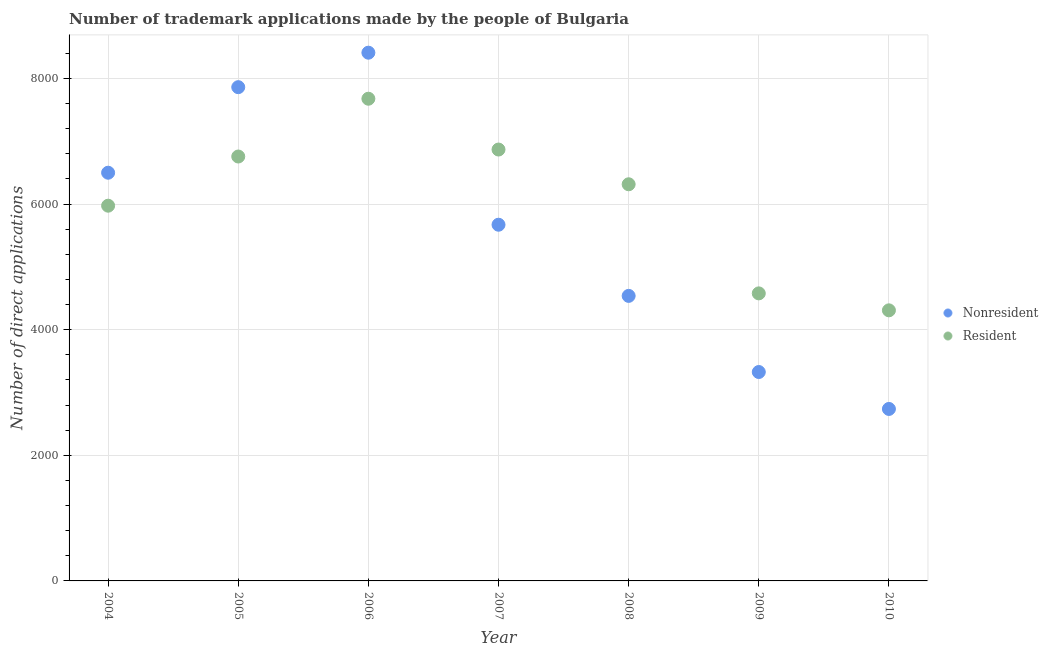What is the number of trademark applications made by non residents in 2004?
Offer a very short reply. 6499. Across all years, what is the maximum number of trademark applications made by non residents?
Provide a short and direct response. 8410. Across all years, what is the minimum number of trademark applications made by residents?
Give a very brief answer. 4308. In which year was the number of trademark applications made by residents maximum?
Your answer should be compact. 2006. In which year was the number of trademark applications made by residents minimum?
Provide a short and direct response. 2010. What is the total number of trademark applications made by non residents in the graph?
Your response must be concise. 3.90e+04. What is the difference between the number of trademark applications made by non residents in 2006 and that in 2009?
Your answer should be very brief. 5084. What is the difference between the number of trademark applications made by residents in 2008 and the number of trademark applications made by non residents in 2004?
Provide a short and direct response. -184. What is the average number of trademark applications made by residents per year?
Your response must be concise. 6068.14. In the year 2005, what is the difference between the number of trademark applications made by non residents and number of trademark applications made by residents?
Ensure brevity in your answer.  1104. In how many years, is the number of trademark applications made by residents greater than 5200?
Make the answer very short. 5. What is the ratio of the number of trademark applications made by residents in 2005 to that in 2010?
Your answer should be very brief. 1.57. Is the difference between the number of trademark applications made by residents in 2004 and 2010 greater than the difference between the number of trademark applications made by non residents in 2004 and 2010?
Offer a terse response. No. What is the difference between the highest and the second highest number of trademark applications made by residents?
Your answer should be very brief. 809. What is the difference between the highest and the lowest number of trademark applications made by residents?
Offer a terse response. 3369. In how many years, is the number of trademark applications made by non residents greater than the average number of trademark applications made by non residents taken over all years?
Provide a short and direct response. 4. Is the sum of the number of trademark applications made by non residents in 2004 and 2008 greater than the maximum number of trademark applications made by residents across all years?
Make the answer very short. Yes. Does the number of trademark applications made by non residents monotonically increase over the years?
Your answer should be compact. No. Is the number of trademark applications made by residents strictly less than the number of trademark applications made by non residents over the years?
Ensure brevity in your answer.  No. How many years are there in the graph?
Provide a short and direct response. 7. Does the graph contain any zero values?
Provide a succinct answer. No. Where does the legend appear in the graph?
Your answer should be very brief. Center right. How many legend labels are there?
Offer a terse response. 2. What is the title of the graph?
Ensure brevity in your answer.  Number of trademark applications made by the people of Bulgaria. What is the label or title of the Y-axis?
Make the answer very short. Number of direct applications. What is the Number of direct applications in Nonresident in 2004?
Your response must be concise. 6499. What is the Number of direct applications of Resident in 2004?
Your response must be concise. 5974. What is the Number of direct applications of Nonresident in 2005?
Provide a short and direct response. 7861. What is the Number of direct applications of Resident in 2005?
Offer a terse response. 6757. What is the Number of direct applications of Nonresident in 2006?
Your answer should be very brief. 8410. What is the Number of direct applications of Resident in 2006?
Ensure brevity in your answer.  7677. What is the Number of direct applications of Nonresident in 2007?
Provide a succinct answer. 5671. What is the Number of direct applications in Resident in 2007?
Provide a succinct answer. 6868. What is the Number of direct applications in Nonresident in 2008?
Keep it short and to the point. 4538. What is the Number of direct applications in Resident in 2008?
Your answer should be very brief. 6315. What is the Number of direct applications in Nonresident in 2009?
Your response must be concise. 3326. What is the Number of direct applications of Resident in 2009?
Your answer should be very brief. 4578. What is the Number of direct applications of Nonresident in 2010?
Make the answer very short. 2738. What is the Number of direct applications of Resident in 2010?
Your answer should be very brief. 4308. Across all years, what is the maximum Number of direct applications of Nonresident?
Offer a terse response. 8410. Across all years, what is the maximum Number of direct applications in Resident?
Make the answer very short. 7677. Across all years, what is the minimum Number of direct applications of Nonresident?
Your response must be concise. 2738. Across all years, what is the minimum Number of direct applications of Resident?
Offer a terse response. 4308. What is the total Number of direct applications of Nonresident in the graph?
Ensure brevity in your answer.  3.90e+04. What is the total Number of direct applications of Resident in the graph?
Give a very brief answer. 4.25e+04. What is the difference between the Number of direct applications in Nonresident in 2004 and that in 2005?
Your response must be concise. -1362. What is the difference between the Number of direct applications of Resident in 2004 and that in 2005?
Ensure brevity in your answer.  -783. What is the difference between the Number of direct applications in Nonresident in 2004 and that in 2006?
Offer a terse response. -1911. What is the difference between the Number of direct applications of Resident in 2004 and that in 2006?
Your answer should be compact. -1703. What is the difference between the Number of direct applications in Nonresident in 2004 and that in 2007?
Provide a succinct answer. 828. What is the difference between the Number of direct applications of Resident in 2004 and that in 2007?
Your answer should be very brief. -894. What is the difference between the Number of direct applications of Nonresident in 2004 and that in 2008?
Your response must be concise. 1961. What is the difference between the Number of direct applications in Resident in 2004 and that in 2008?
Give a very brief answer. -341. What is the difference between the Number of direct applications in Nonresident in 2004 and that in 2009?
Give a very brief answer. 3173. What is the difference between the Number of direct applications of Resident in 2004 and that in 2009?
Your answer should be compact. 1396. What is the difference between the Number of direct applications of Nonresident in 2004 and that in 2010?
Your answer should be compact. 3761. What is the difference between the Number of direct applications of Resident in 2004 and that in 2010?
Ensure brevity in your answer.  1666. What is the difference between the Number of direct applications in Nonresident in 2005 and that in 2006?
Give a very brief answer. -549. What is the difference between the Number of direct applications in Resident in 2005 and that in 2006?
Make the answer very short. -920. What is the difference between the Number of direct applications of Nonresident in 2005 and that in 2007?
Make the answer very short. 2190. What is the difference between the Number of direct applications of Resident in 2005 and that in 2007?
Provide a short and direct response. -111. What is the difference between the Number of direct applications of Nonresident in 2005 and that in 2008?
Your answer should be very brief. 3323. What is the difference between the Number of direct applications in Resident in 2005 and that in 2008?
Provide a succinct answer. 442. What is the difference between the Number of direct applications in Nonresident in 2005 and that in 2009?
Make the answer very short. 4535. What is the difference between the Number of direct applications of Resident in 2005 and that in 2009?
Give a very brief answer. 2179. What is the difference between the Number of direct applications of Nonresident in 2005 and that in 2010?
Ensure brevity in your answer.  5123. What is the difference between the Number of direct applications of Resident in 2005 and that in 2010?
Offer a terse response. 2449. What is the difference between the Number of direct applications of Nonresident in 2006 and that in 2007?
Your response must be concise. 2739. What is the difference between the Number of direct applications in Resident in 2006 and that in 2007?
Your answer should be compact. 809. What is the difference between the Number of direct applications in Nonresident in 2006 and that in 2008?
Your response must be concise. 3872. What is the difference between the Number of direct applications of Resident in 2006 and that in 2008?
Ensure brevity in your answer.  1362. What is the difference between the Number of direct applications of Nonresident in 2006 and that in 2009?
Your response must be concise. 5084. What is the difference between the Number of direct applications in Resident in 2006 and that in 2009?
Give a very brief answer. 3099. What is the difference between the Number of direct applications in Nonresident in 2006 and that in 2010?
Provide a short and direct response. 5672. What is the difference between the Number of direct applications in Resident in 2006 and that in 2010?
Ensure brevity in your answer.  3369. What is the difference between the Number of direct applications in Nonresident in 2007 and that in 2008?
Provide a succinct answer. 1133. What is the difference between the Number of direct applications of Resident in 2007 and that in 2008?
Your answer should be very brief. 553. What is the difference between the Number of direct applications of Nonresident in 2007 and that in 2009?
Provide a succinct answer. 2345. What is the difference between the Number of direct applications of Resident in 2007 and that in 2009?
Provide a short and direct response. 2290. What is the difference between the Number of direct applications of Nonresident in 2007 and that in 2010?
Give a very brief answer. 2933. What is the difference between the Number of direct applications in Resident in 2007 and that in 2010?
Your response must be concise. 2560. What is the difference between the Number of direct applications in Nonresident in 2008 and that in 2009?
Ensure brevity in your answer.  1212. What is the difference between the Number of direct applications of Resident in 2008 and that in 2009?
Provide a succinct answer. 1737. What is the difference between the Number of direct applications of Nonresident in 2008 and that in 2010?
Make the answer very short. 1800. What is the difference between the Number of direct applications of Resident in 2008 and that in 2010?
Provide a succinct answer. 2007. What is the difference between the Number of direct applications in Nonresident in 2009 and that in 2010?
Provide a succinct answer. 588. What is the difference between the Number of direct applications of Resident in 2009 and that in 2010?
Your answer should be compact. 270. What is the difference between the Number of direct applications in Nonresident in 2004 and the Number of direct applications in Resident in 2005?
Ensure brevity in your answer.  -258. What is the difference between the Number of direct applications in Nonresident in 2004 and the Number of direct applications in Resident in 2006?
Keep it short and to the point. -1178. What is the difference between the Number of direct applications of Nonresident in 2004 and the Number of direct applications of Resident in 2007?
Offer a terse response. -369. What is the difference between the Number of direct applications in Nonresident in 2004 and the Number of direct applications in Resident in 2008?
Provide a short and direct response. 184. What is the difference between the Number of direct applications in Nonresident in 2004 and the Number of direct applications in Resident in 2009?
Provide a short and direct response. 1921. What is the difference between the Number of direct applications in Nonresident in 2004 and the Number of direct applications in Resident in 2010?
Ensure brevity in your answer.  2191. What is the difference between the Number of direct applications in Nonresident in 2005 and the Number of direct applications in Resident in 2006?
Give a very brief answer. 184. What is the difference between the Number of direct applications of Nonresident in 2005 and the Number of direct applications of Resident in 2007?
Provide a succinct answer. 993. What is the difference between the Number of direct applications of Nonresident in 2005 and the Number of direct applications of Resident in 2008?
Offer a very short reply. 1546. What is the difference between the Number of direct applications in Nonresident in 2005 and the Number of direct applications in Resident in 2009?
Keep it short and to the point. 3283. What is the difference between the Number of direct applications of Nonresident in 2005 and the Number of direct applications of Resident in 2010?
Offer a terse response. 3553. What is the difference between the Number of direct applications in Nonresident in 2006 and the Number of direct applications in Resident in 2007?
Offer a terse response. 1542. What is the difference between the Number of direct applications of Nonresident in 2006 and the Number of direct applications of Resident in 2008?
Your answer should be very brief. 2095. What is the difference between the Number of direct applications in Nonresident in 2006 and the Number of direct applications in Resident in 2009?
Provide a short and direct response. 3832. What is the difference between the Number of direct applications in Nonresident in 2006 and the Number of direct applications in Resident in 2010?
Make the answer very short. 4102. What is the difference between the Number of direct applications in Nonresident in 2007 and the Number of direct applications in Resident in 2008?
Keep it short and to the point. -644. What is the difference between the Number of direct applications in Nonresident in 2007 and the Number of direct applications in Resident in 2009?
Ensure brevity in your answer.  1093. What is the difference between the Number of direct applications in Nonresident in 2007 and the Number of direct applications in Resident in 2010?
Provide a short and direct response. 1363. What is the difference between the Number of direct applications in Nonresident in 2008 and the Number of direct applications in Resident in 2009?
Your response must be concise. -40. What is the difference between the Number of direct applications in Nonresident in 2008 and the Number of direct applications in Resident in 2010?
Keep it short and to the point. 230. What is the difference between the Number of direct applications in Nonresident in 2009 and the Number of direct applications in Resident in 2010?
Your response must be concise. -982. What is the average Number of direct applications in Nonresident per year?
Your answer should be compact. 5577.57. What is the average Number of direct applications of Resident per year?
Your response must be concise. 6068.14. In the year 2004, what is the difference between the Number of direct applications in Nonresident and Number of direct applications in Resident?
Provide a short and direct response. 525. In the year 2005, what is the difference between the Number of direct applications of Nonresident and Number of direct applications of Resident?
Make the answer very short. 1104. In the year 2006, what is the difference between the Number of direct applications in Nonresident and Number of direct applications in Resident?
Ensure brevity in your answer.  733. In the year 2007, what is the difference between the Number of direct applications of Nonresident and Number of direct applications of Resident?
Provide a succinct answer. -1197. In the year 2008, what is the difference between the Number of direct applications in Nonresident and Number of direct applications in Resident?
Offer a terse response. -1777. In the year 2009, what is the difference between the Number of direct applications of Nonresident and Number of direct applications of Resident?
Provide a succinct answer. -1252. In the year 2010, what is the difference between the Number of direct applications of Nonresident and Number of direct applications of Resident?
Keep it short and to the point. -1570. What is the ratio of the Number of direct applications of Nonresident in 2004 to that in 2005?
Your answer should be compact. 0.83. What is the ratio of the Number of direct applications of Resident in 2004 to that in 2005?
Make the answer very short. 0.88. What is the ratio of the Number of direct applications of Nonresident in 2004 to that in 2006?
Keep it short and to the point. 0.77. What is the ratio of the Number of direct applications of Resident in 2004 to that in 2006?
Provide a short and direct response. 0.78. What is the ratio of the Number of direct applications in Nonresident in 2004 to that in 2007?
Make the answer very short. 1.15. What is the ratio of the Number of direct applications of Resident in 2004 to that in 2007?
Your response must be concise. 0.87. What is the ratio of the Number of direct applications in Nonresident in 2004 to that in 2008?
Your response must be concise. 1.43. What is the ratio of the Number of direct applications in Resident in 2004 to that in 2008?
Offer a terse response. 0.95. What is the ratio of the Number of direct applications of Nonresident in 2004 to that in 2009?
Provide a short and direct response. 1.95. What is the ratio of the Number of direct applications in Resident in 2004 to that in 2009?
Provide a succinct answer. 1.3. What is the ratio of the Number of direct applications of Nonresident in 2004 to that in 2010?
Provide a short and direct response. 2.37. What is the ratio of the Number of direct applications in Resident in 2004 to that in 2010?
Your answer should be very brief. 1.39. What is the ratio of the Number of direct applications of Nonresident in 2005 to that in 2006?
Your answer should be compact. 0.93. What is the ratio of the Number of direct applications in Resident in 2005 to that in 2006?
Ensure brevity in your answer.  0.88. What is the ratio of the Number of direct applications of Nonresident in 2005 to that in 2007?
Provide a succinct answer. 1.39. What is the ratio of the Number of direct applications of Resident in 2005 to that in 2007?
Your answer should be very brief. 0.98. What is the ratio of the Number of direct applications in Nonresident in 2005 to that in 2008?
Provide a short and direct response. 1.73. What is the ratio of the Number of direct applications in Resident in 2005 to that in 2008?
Your response must be concise. 1.07. What is the ratio of the Number of direct applications in Nonresident in 2005 to that in 2009?
Your answer should be very brief. 2.36. What is the ratio of the Number of direct applications of Resident in 2005 to that in 2009?
Keep it short and to the point. 1.48. What is the ratio of the Number of direct applications of Nonresident in 2005 to that in 2010?
Your answer should be compact. 2.87. What is the ratio of the Number of direct applications of Resident in 2005 to that in 2010?
Keep it short and to the point. 1.57. What is the ratio of the Number of direct applications in Nonresident in 2006 to that in 2007?
Your answer should be very brief. 1.48. What is the ratio of the Number of direct applications in Resident in 2006 to that in 2007?
Ensure brevity in your answer.  1.12. What is the ratio of the Number of direct applications of Nonresident in 2006 to that in 2008?
Provide a short and direct response. 1.85. What is the ratio of the Number of direct applications of Resident in 2006 to that in 2008?
Provide a short and direct response. 1.22. What is the ratio of the Number of direct applications in Nonresident in 2006 to that in 2009?
Give a very brief answer. 2.53. What is the ratio of the Number of direct applications in Resident in 2006 to that in 2009?
Give a very brief answer. 1.68. What is the ratio of the Number of direct applications of Nonresident in 2006 to that in 2010?
Your answer should be compact. 3.07. What is the ratio of the Number of direct applications of Resident in 2006 to that in 2010?
Give a very brief answer. 1.78. What is the ratio of the Number of direct applications in Nonresident in 2007 to that in 2008?
Ensure brevity in your answer.  1.25. What is the ratio of the Number of direct applications of Resident in 2007 to that in 2008?
Give a very brief answer. 1.09. What is the ratio of the Number of direct applications in Nonresident in 2007 to that in 2009?
Your answer should be compact. 1.71. What is the ratio of the Number of direct applications in Resident in 2007 to that in 2009?
Ensure brevity in your answer.  1.5. What is the ratio of the Number of direct applications of Nonresident in 2007 to that in 2010?
Your response must be concise. 2.07. What is the ratio of the Number of direct applications in Resident in 2007 to that in 2010?
Your response must be concise. 1.59. What is the ratio of the Number of direct applications in Nonresident in 2008 to that in 2009?
Your answer should be very brief. 1.36. What is the ratio of the Number of direct applications of Resident in 2008 to that in 2009?
Offer a very short reply. 1.38. What is the ratio of the Number of direct applications in Nonresident in 2008 to that in 2010?
Provide a short and direct response. 1.66. What is the ratio of the Number of direct applications of Resident in 2008 to that in 2010?
Offer a very short reply. 1.47. What is the ratio of the Number of direct applications of Nonresident in 2009 to that in 2010?
Your response must be concise. 1.21. What is the ratio of the Number of direct applications of Resident in 2009 to that in 2010?
Your answer should be compact. 1.06. What is the difference between the highest and the second highest Number of direct applications of Nonresident?
Make the answer very short. 549. What is the difference between the highest and the second highest Number of direct applications in Resident?
Offer a very short reply. 809. What is the difference between the highest and the lowest Number of direct applications of Nonresident?
Make the answer very short. 5672. What is the difference between the highest and the lowest Number of direct applications of Resident?
Provide a succinct answer. 3369. 